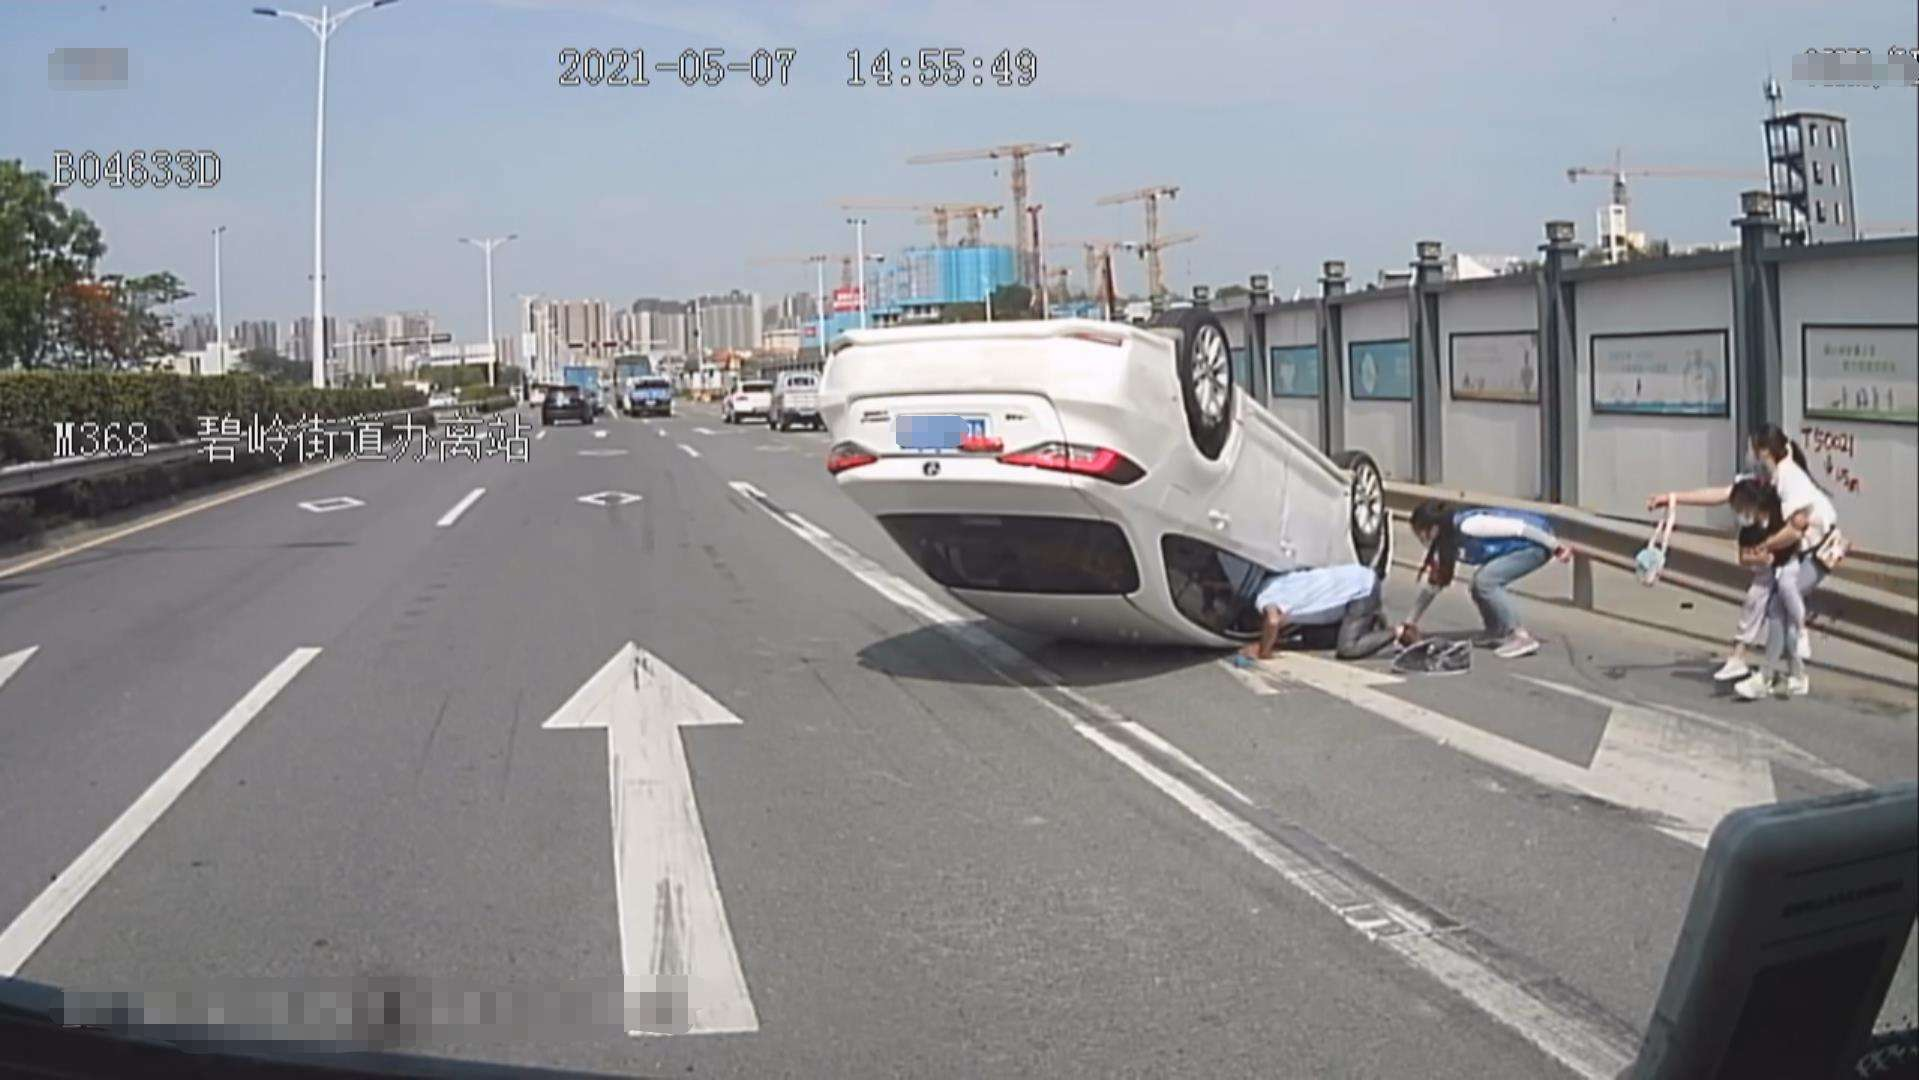What other details can you give me about the surroundings? The surroundings in the image include a clear sky indicating good weather conditions which might not be a factor in the accident. There are several high-rise buildings in the distance, indicating a densely populated urban area. Construction cranes are visible as well, hinting at ongoing development nearby. The road appears to be in good condition, with clearly marked lanes and traffic signs helping to regulate vehicle movement. 